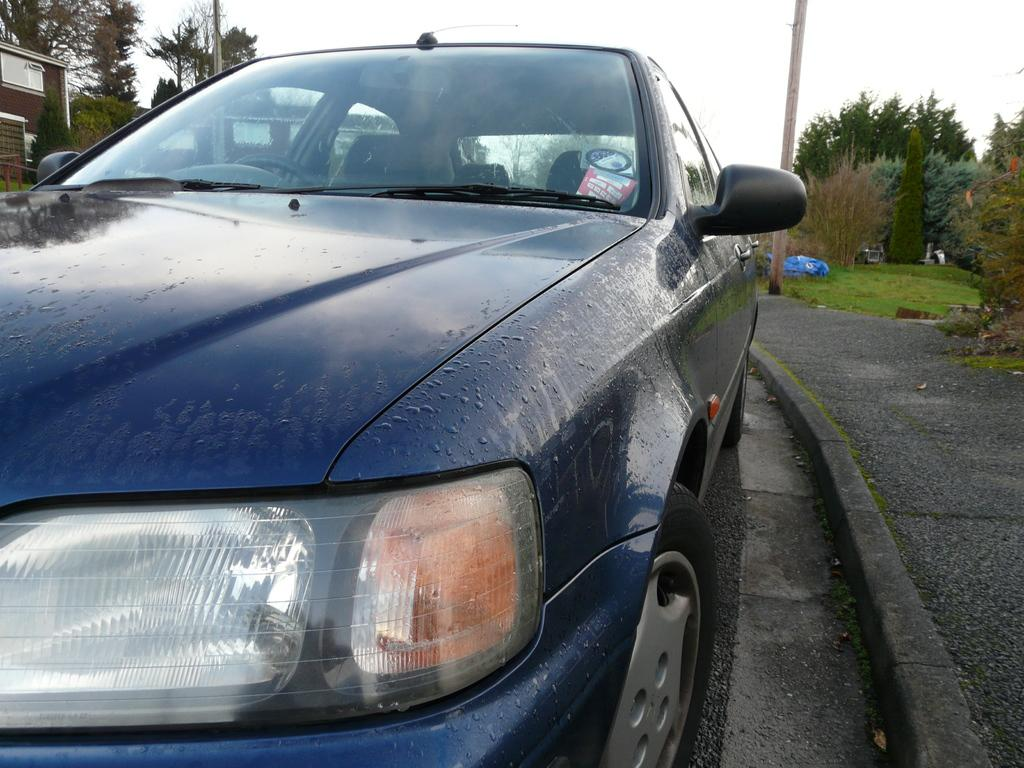What is the main subject in the middle of the image? There is a car in the middle of the image. What structure can be seen on the left side of the image? There is a building on the left side of the image. What type of vegetation is present on both sides of the image? There are trees on either side of the image. What is visible at the top of the image? The sky is visible at the top of the image. How many rings are visible on the car's tires in the image? There are no rings visible on the car's tires in the image. What type of card is being used to pay for parking in the image? There is no card or parking payment depicted in the image. 